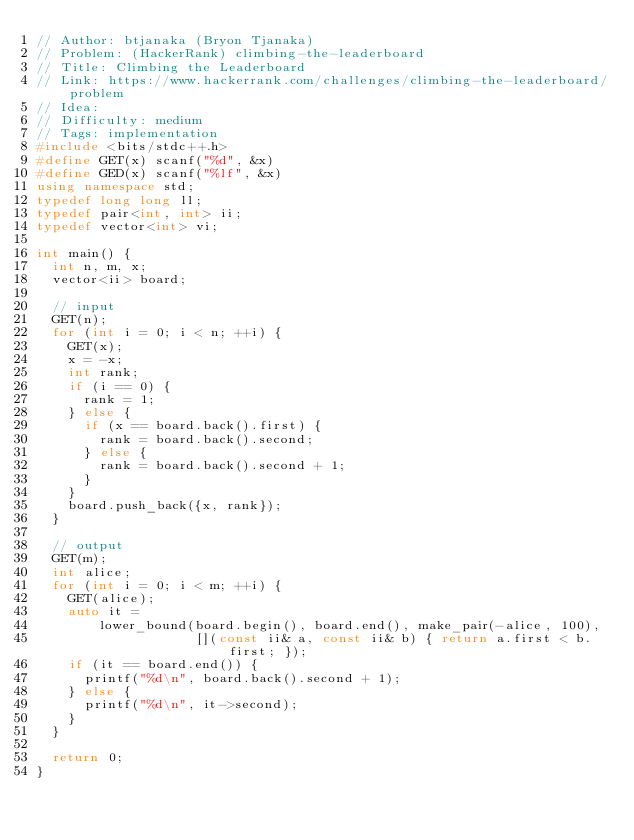<code> <loc_0><loc_0><loc_500><loc_500><_C++_>// Author: btjanaka (Bryon Tjanaka)
// Problem: (HackerRank) climbing-the-leaderboard
// Title: Climbing the Leaderboard
// Link: https://www.hackerrank.com/challenges/climbing-the-leaderboard/problem
// Idea:
// Difficulty: medium
// Tags: implementation
#include <bits/stdc++.h>
#define GET(x) scanf("%d", &x)
#define GED(x) scanf("%lf", &x)
using namespace std;
typedef long long ll;
typedef pair<int, int> ii;
typedef vector<int> vi;

int main() {
  int n, m, x;
  vector<ii> board;

  // input
  GET(n);
  for (int i = 0; i < n; ++i) {
    GET(x);
    x = -x;
    int rank;
    if (i == 0) {
      rank = 1;
    } else {
      if (x == board.back().first) {
        rank = board.back().second;
      } else {
        rank = board.back().second + 1;
      }
    }
    board.push_back({x, rank});
  }

  // output
  GET(m);
  int alice;
  for (int i = 0; i < m; ++i) {
    GET(alice);
    auto it =
        lower_bound(board.begin(), board.end(), make_pair(-alice, 100),
                    [](const ii& a, const ii& b) { return a.first < b.first; });
    if (it == board.end()) {
      printf("%d\n", board.back().second + 1);
    } else {
      printf("%d\n", it->second);
    }
  }

  return 0;
}
</code> 